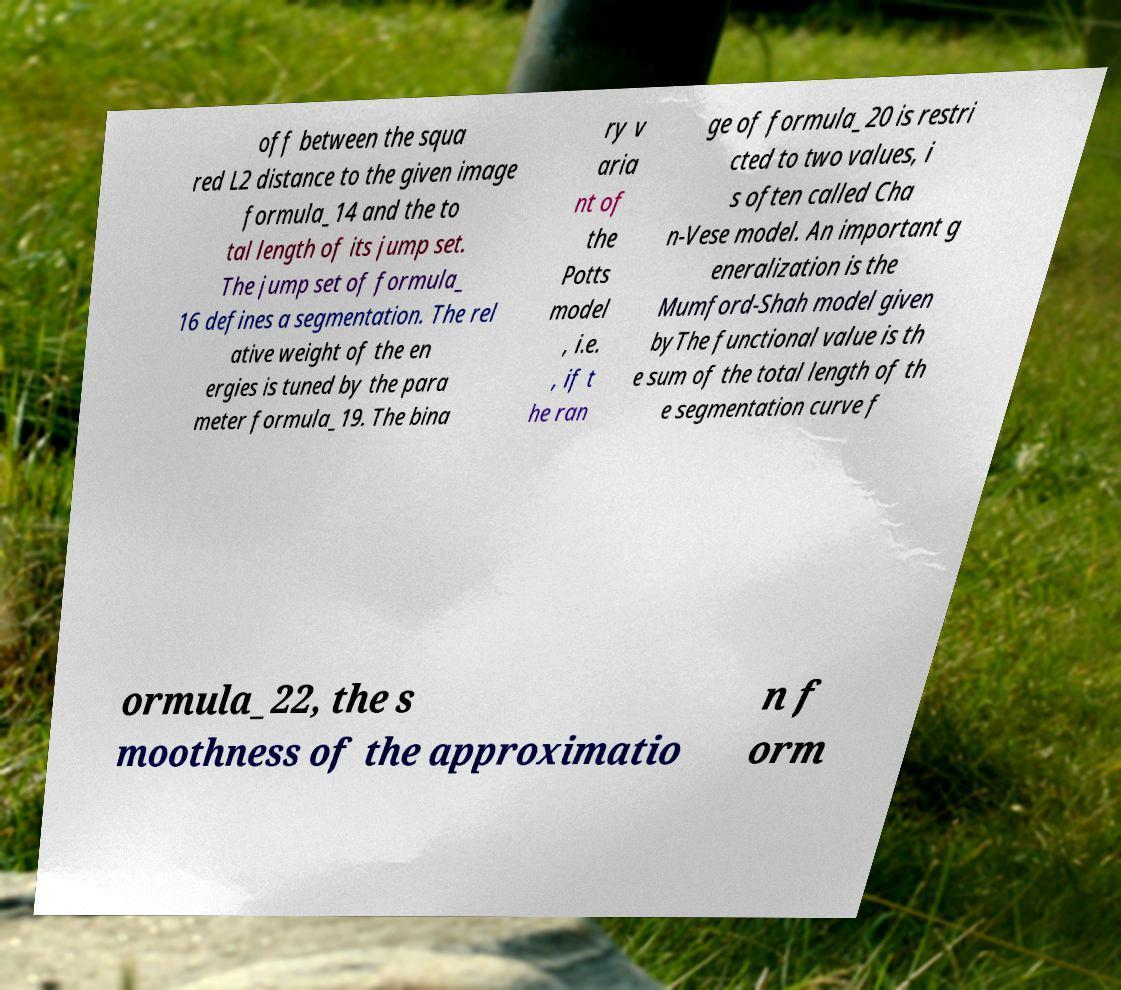For documentation purposes, I need the text within this image transcribed. Could you provide that? off between the squa red L2 distance to the given image formula_14 and the to tal length of its jump set. The jump set of formula_ 16 defines a segmentation. The rel ative weight of the en ergies is tuned by the para meter formula_19. The bina ry v aria nt of the Potts model , i.e. , if t he ran ge of formula_20 is restri cted to two values, i s often called Cha n-Vese model. An important g eneralization is the Mumford-Shah model given byThe functional value is th e sum of the total length of th e segmentation curve f ormula_22, the s moothness of the approximatio n f orm 